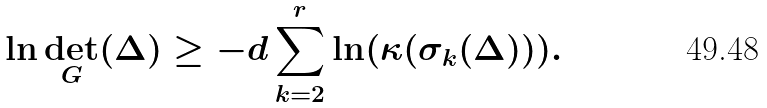Convert formula to latex. <formula><loc_0><loc_0><loc_500><loc_500>\ln \det _ { G } ( \Delta ) \geq - d \sum _ { k = 2 } ^ { r } \ln ( \kappa ( \sigma _ { k } ( \Delta ) ) ) .</formula> 